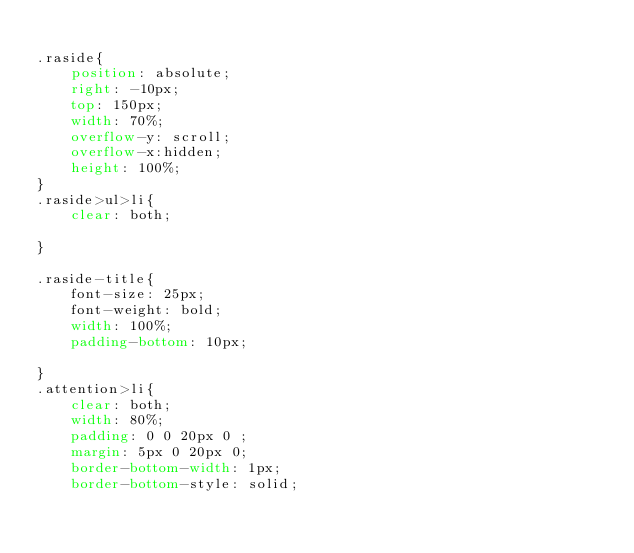<code> <loc_0><loc_0><loc_500><loc_500><_CSS_>
.raside{
    position: absolute;
    right: -10px;
    top: 150px;
    width: 70%;
    overflow-y: scroll;
    overflow-x:hidden;
    height: 100%;
}
.raside>ul>li{
    clear: both;

}

.raside-title{
    font-size: 25px;
    font-weight: bold;
    width: 100%;
    padding-bottom: 10px;

}
.attention>li{
    clear: both;
    width: 80%;
    padding: 0 0 20px 0 ;
    margin: 5px 0 20px 0;
    border-bottom-width: 1px;
    border-bottom-style: solid;</code> 